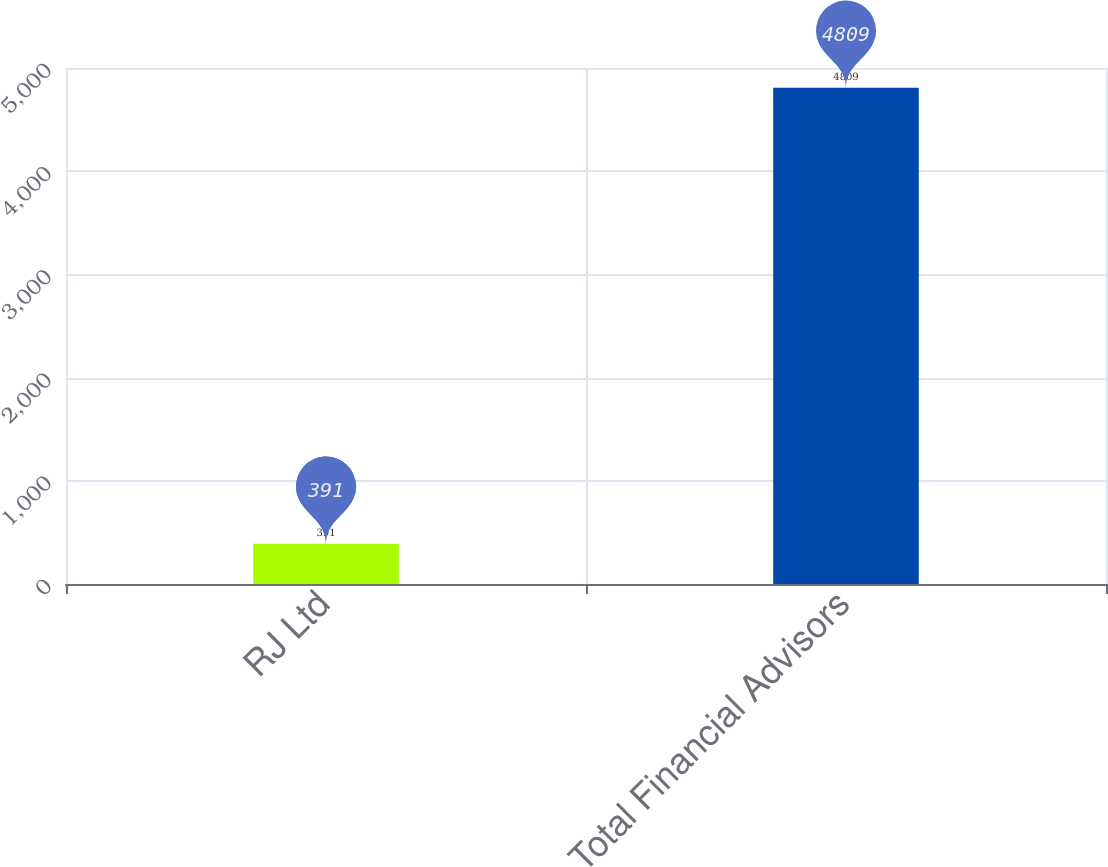Convert chart. <chart><loc_0><loc_0><loc_500><loc_500><bar_chart><fcel>RJ Ltd<fcel>Total Financial Advisors<nl><fcel>391<fcel>4809<nl></chart> 